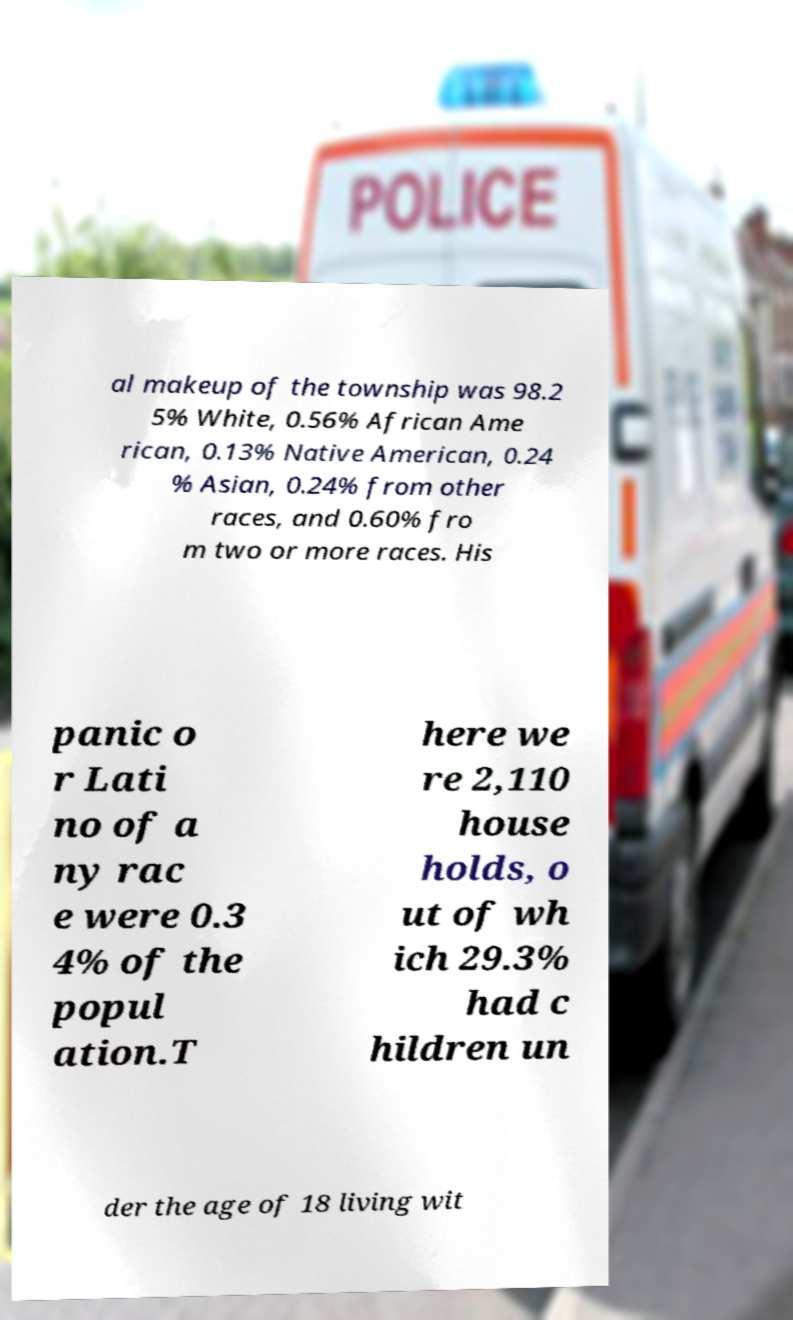Can you read and provide the text displayed in the image?This photo seems to have some interesting text. Can you extract and type it out for me? al makeup of the township was 98.2 5% White, 0.56% African Ame rican, 0.13% Native American, 0.24 % Asian, 0.24% from other races, and 0.60% fro m two or more races. His panic o r Lati no of a ny rac e were 0.3 4% of the popul ation.T here we re 2,110 house holds, o ut of wh ich 29.3% had c hildren un der the age of 18 living wit 